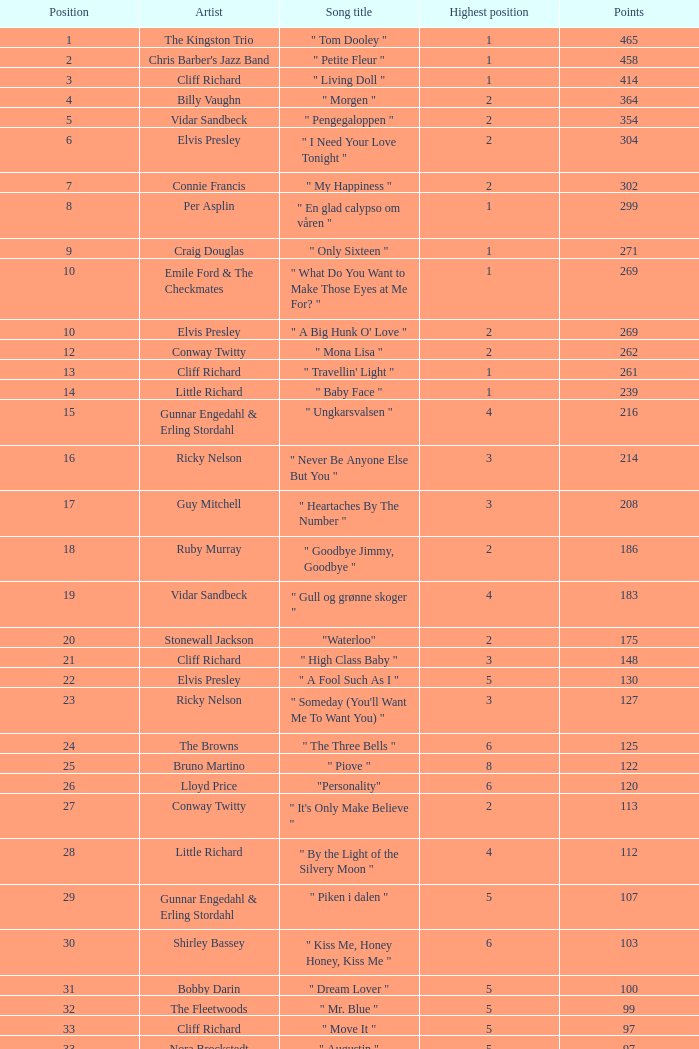Can you provide the name of the song that was performed by billy vaughn? " Morgen ". Parse the full table. {'header': ['Position', 'Artist', 'Song title', 'Highest position', 'Points'], 'rows': [['1', 'The Kingston Trio', '" Tom Dooley "', '1', '465'], ['2', "Chris Barber's Jazz Band", '" Petite Fleur "', '1', '458'], ['3', 'Cliff Richard', '" Living Doll "', '1', '414'], ['4', 'Billy Vaughn', '" Morgen "', '2', '364'], ['5', 'Vidar Sandbeck', '" Pengegaloppen "', '2', '354'], ['6', 'Elvis Presley', '" I Need Your Love Tonight "', '2', '304'], ['7', 'Connie Francis', '" My Happiness "', '2', '302'], ['8', 'Per Asplin', '" En glad calypso om våren "', '1', '299'], ['9', 'Craig Douglas', '" Only Sixteen "', '1', '271'], ['10', 'Emile Ford & The Checkmates', '" What Do You Want to Make Those Eyes at Me For? "', '1', '269'], ['10', 'Elvis Presley', '" A Big Hunk O\' Love "', '2', '269'], ['12', 'Conway Twitty', '" Mona Lisa "', '2', '262'], ['13', 'Cliff Richard', '" Travellin\' Light "', '1', '261'], ['14', 'Little Richard', '" Baby Face "', '1', '239'], ['15', 'Gunnar Engedahl & Erling Stordahl', '" Ungkarsvalsen "', '4', '216'], ['16', 'Ricky Nelson', '" Never Be Anyone Else But You "', '3', '214'], ['17', 'Guy Mitchell', '" Heartaches By The Number "', '3', '208'], ['18', 'Ruby Murray', '" Goodbye Jimmy, Goodbye "', '2', '186'], ['19', 'Vidar Sandbeck', '" Gull og grønne skoger "', '4', '183'], ['20', 'Stonewall Jackson', '"Waterloo"', '2', '175'], ['21', 'Cliff Richard', '" High Class Baby "', '3', '148'], ['22', 'Elvis Presley', '" A Fool Such As I "', '5', '130'], ['23', 'Ricky Nelson', '" Someday (You\'ll Want Me To Want You) "', '3', '127'], ['24', 'The Browns', '" The Three Bells "', '6', '125'], ['25', 'Bruno Martino', '" Piove "', '8', '122'], ['26', 'Lloyd Price', '"Personality"', '6', '120'], ['27', 'Conway Twitty', '" It\'s Only Make Believe "', '2', '113'], ['28', 'Little Richard', '" By the Light of the Silvery Moon "', '4', '112'], ['29', 'Gunnar Engedahl & Erling Stordahl', '" Piken i dalen "', '5', '107'], ['30', 'Shirley Bassey', '" Kiss Me, Honey Honey, Kiss Me "', '6', '103'], ['31', 'Bobby Darin', '" Dream Lover "', '5', '100'], ['32', 'The Fleetwoods', '" Mr. Blue "', '5', '99'], ['33', 'Cliff Richard', '" Move It "', '5', '97'], ['33', 'Nora Brockstedt', '" Augustin "', '5', '97'], ['35', 'The Coasters', '" Charlie Brown "', '5', '85'], ['36', 'Cliff Richard', '" Never Mind "', '5', '82'], ['37', 'Jerry Keller', '" Here Comes Summer "', '8', '73'], ['38', 'Connie Francis', '" Lipstick On Your Collar "', '7', '80'], ['39', 'Lloyd Price', '" Stagger Lee "', '8', '58'], ['40', 'Floyd Robinson', '" Makin\' Love "', '7', '53'], ['41', 'Jane Morgan', '" The Day The Rains Came "', '7', '49'], ['42', 'Bing Crosby', '" White Christmas "', '6', '41'], ['43', 'Paul Anka', '" Lonely Boy "', '9', '36'], ['44', 'Bobby Darin', '" Mack The Knife "', '9', '34'], ['45', 'Pat Boone', '" I\'ll Remember Tonight "', '9', '23'], ['46', 'Sam Cooke', '" Only Sixteen "', '10', '22'], ['47', 'Bruno Martino', '" Come prima "', '9', '12']]} 